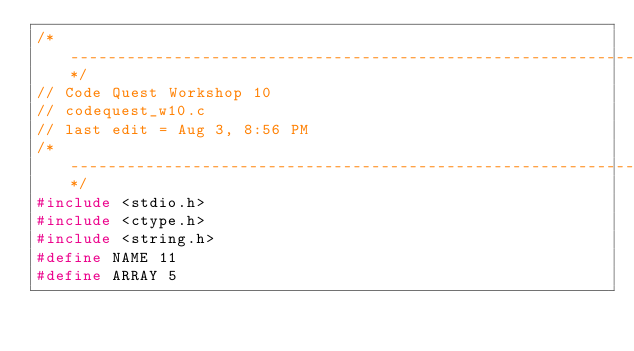Convert code to text. <code><loc_0><loc_0><loc_500><loc_500><_C_>/*-----------------------------------------------------------------------------------------------*/
// Code Quest Workshop 10
// codequest_w10.c
// last edit = Aug 3, 8:56 PM
/*-----------------------------------------------------------------------------------------------*/
#include <stdio.h>
#include <ctype.h>
#include <string.h>
#define NAME 11
#define ARRAY 5</code> 